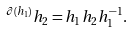<formula> <loc_0><loc_0><loc_500><loc_500>^ { \partial ( h _ { 1 } ) } h _ { 2 } = h _ { 1 } h _ { 2 } h _ { 1 } ^ { - 1 } .</formula> 